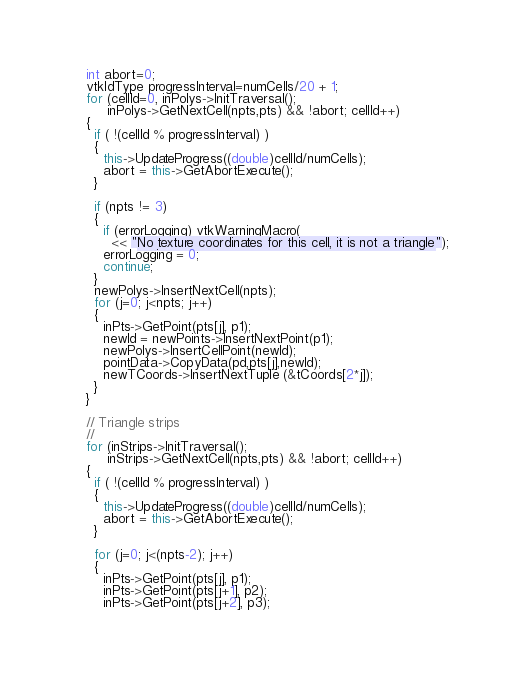<code> <loc_0><loc_0><loc_500><loc_500><_C++_>  int abort=0;
  vtkIdType progressInterval=numCells/20 + 1;
  for (cellId=0, inPolys->InitTraversal();
       inPolys->GetNextCell(npts,pts) && !abort; cellId++)
  {
    if ( !(cellId % progressInterval) )
    {
      this->UpdateProgress((double)cellId/numCells);
      abort = this->GetAbortExecute();
    }

    if (npts != 3)
    {
      if (errorLogging) vtkWarningMacro(
        << "No texture coordinates for this cell, it is not a triangle");
      errorLogging = 0;
      continue;
    }
    newPolys->InsertNextCell(npts);
    for (j=0; j<npts; j++)
    {
      inPts->GetPoint(pts[j], p1);
      newId = newPoints->InsertNextPoint(p1);
      newPolys->InsertCellPoint(newId);
      pointData->CopyData(pd,pts[j],newId);
      newTCoords->InsertNextTuple (&tCoords[2*j]);
    }
  }

  // Triangle strips
  //
  for (inStrips->InitTraversal();
       inStrips->GetNextCell(npts,pts) && !abort; cellId++)
  {
    if ( !(cellId % progressInterval) )
    {
      this->UpdateProgress((double)cellId/numCells);
      abort = this->GetAbortExecute();
    }

    for (j=0; j<(npts-2); j++)
    {
      inPts->GetPoint(pts[j], p1);
      inPts->GetPoint(pts[j+1], p2);
      inPts->GetPoint(pts[j+2], p3);
</code> 